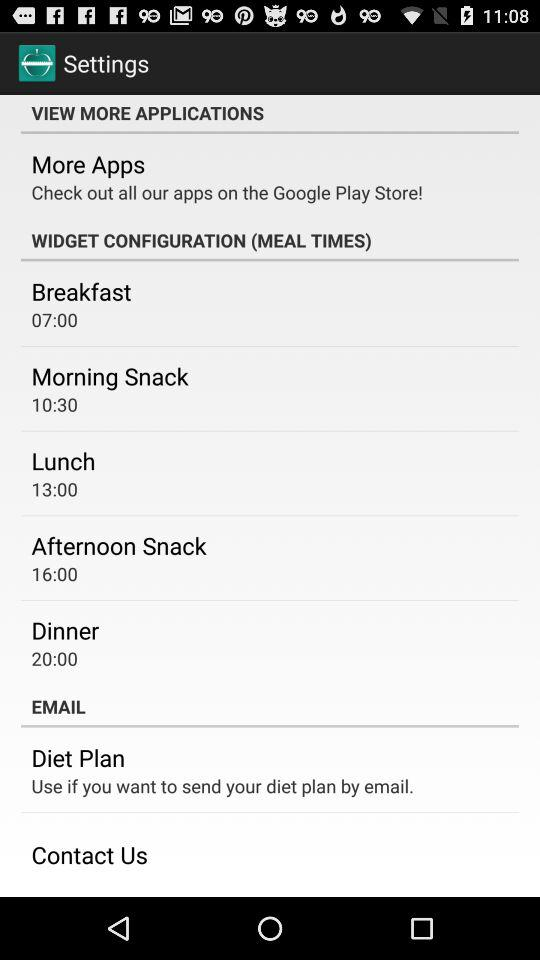What is the time for the afternoon snack? The time for the afternoon snack is 16:00. 